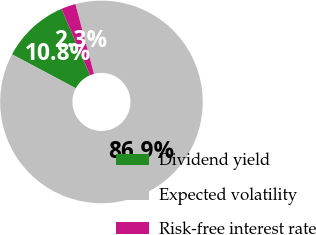Convert chart to OTSL. <chart><loc_0><loc_0><loc_500><loc_500><pie_chart><fcel>Dividend yield<fcel>Expected volatility<fcel>Risk-free interest rate<nl><fcel>10.77%<fcel>86.91%<fcel>2.31%<nl></chart> 